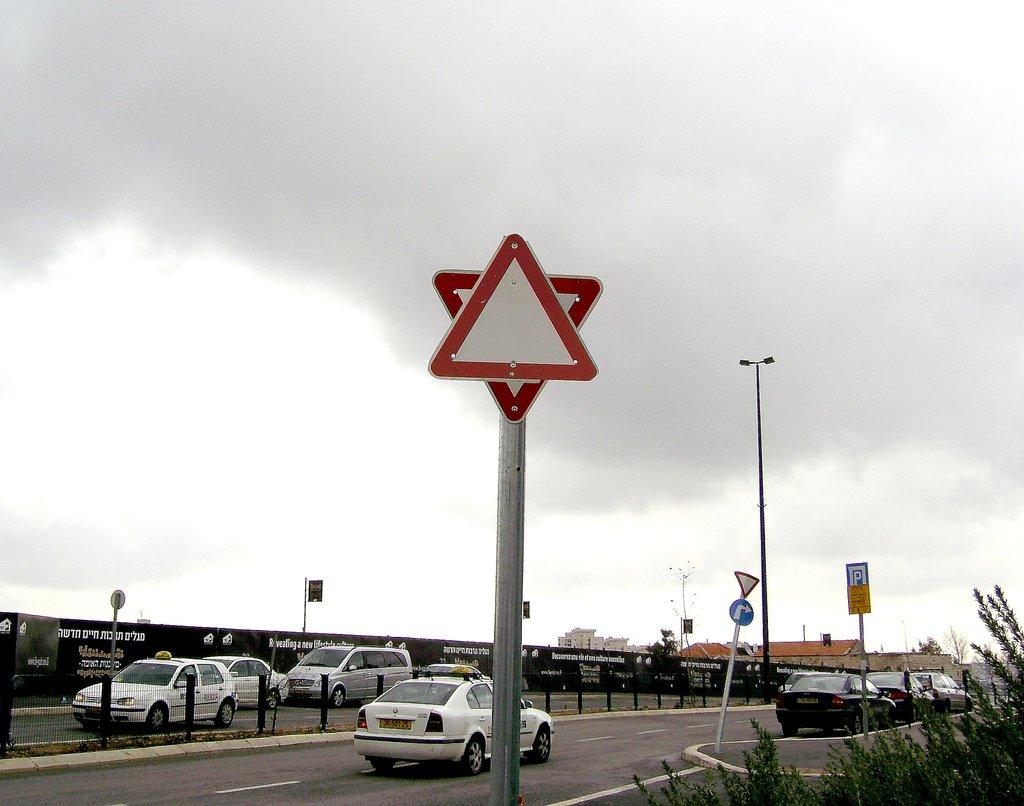What is attached to the poles in the image? There are boards and lights attached to poles in the image. What type of barrier can be seen in the image? There is a fence in the image. What type of vegetation is present in the image? There are plants in the image. What type of advertising is present in the image? There are hoardings in the image. What type of transportation is visible on the road in the image? There are vehicles on the road in the image. What can be seen in the background of the image? The sky is visible in the background of the image. What type of punishment is being administered to the cattle in the image? There are no cattle present in the image, and therefore no punishment is being administered. What year is depicted in the image? The image does not depict a specific year; it is a snapshot of a scene at a particular moment in time. 